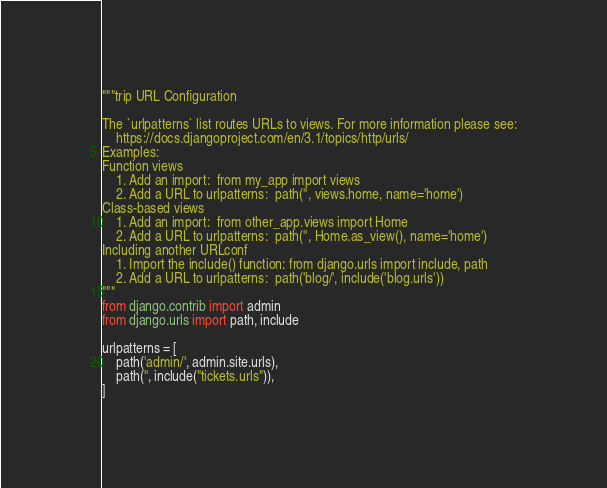Convert code to text. <code><loc_0><loc_0><loc_500><loc_500><_Python_>"""trip URL Configuration

The `urlpatterns` list routes URLs to views. For more information please see:
    https://docs.djangoproject.com/en/3.1/topics/http/urls/
Examples:
Function views
    1. Add an import:  from my_app import views
    2. Add a URL to urlpatterns:  path('', views.home, name='home')
Class-based views
    1. Add an import:  from other_app.views import Home
    2. Add a URL to urlpatterns:  path('', Home.as_view(), name='home')
Including another URLconf
    1. Import the include() function: from django.urls import include, path
    2. Add a URL to urlpatterns:  path('blog/', include('blog.urls'))
"""
from django.contrib import admin
from django.urls import path, include

urlpatterns = [
    path('admin/', admin.site.urls),
    path('', include("tickets.urls")),
]
</code> 